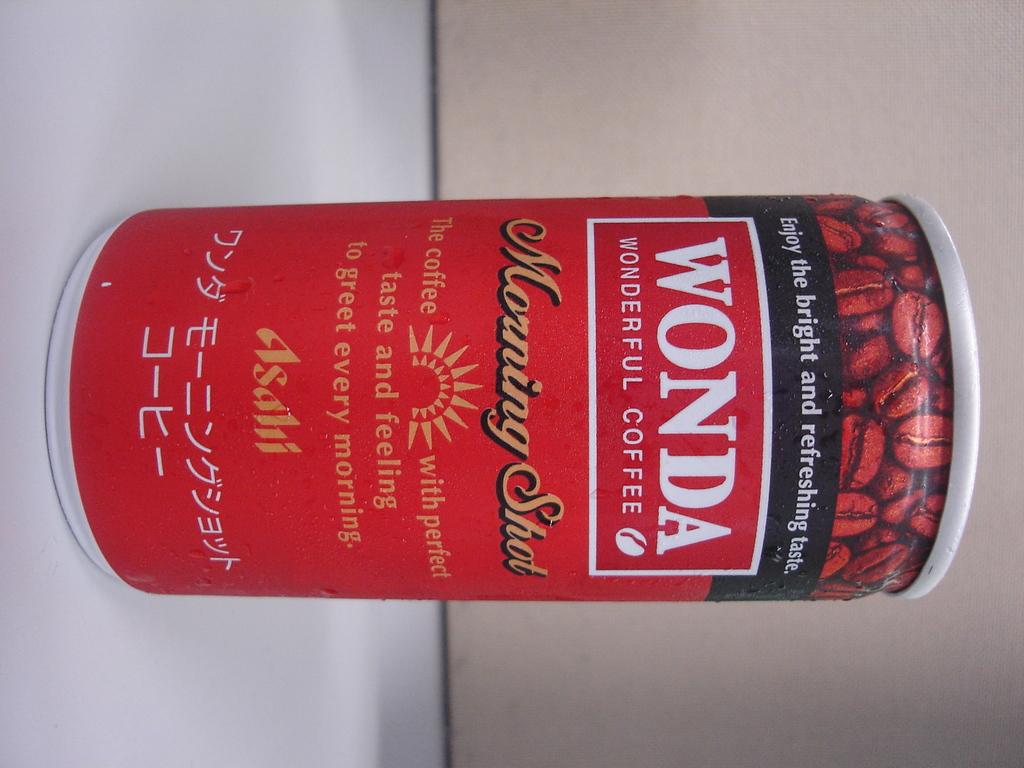What is the brand?
Offer a very short reply. Wonda. 